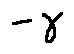<formula> <loc_0><loc_0><loc_500><loc_500>- \gamma</formula> 